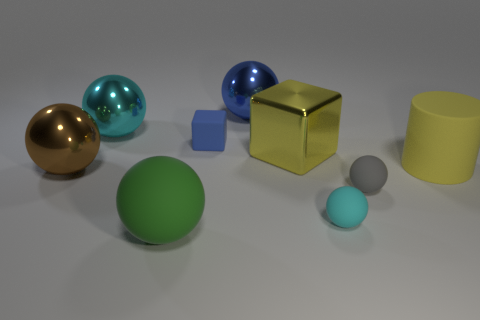Subtract all tiny cyan balls. How many balls are left? 5 Add 1 small red cubes. How many objects exist? 10 Subtract 3 balls. How many balls are left? 3 Subtract all green balls. How many balls are left? 5 Subtract all spheres. How many objects are left? 3 Subtract all purple blocks. How many cyan balls are left? 2 Subtract all green cylinders. Subtract all brown blocks. How many cylinders are left? 1 Subtract all big cyan metallic things. Subtract all big brown metal blocks. How many objects are left? 8 Add 4 large yellow blocks. How many large yellow blocks are left? 5 Add 3 tiny matte objects. How many tiny matte objects exist? 6 